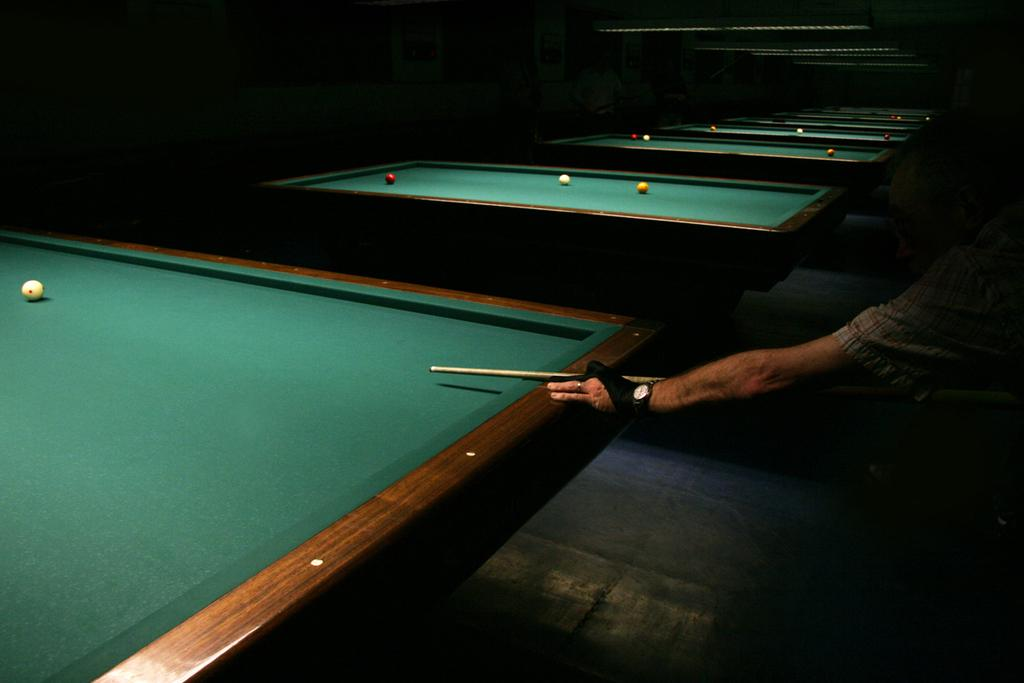What activity is the person in the image engaged in? The person is playing billiards in the image. What object is the person holding while playing billiards? The person is holding a stick, likely a billiard cue, while playing billiards. What can be seen in the background of the image? There are multiple billiard game tables in the background of the image. What type of cover is the squirrel wearing in the image? There is no squirrel present in the image, so it is not possible to answer that question. 